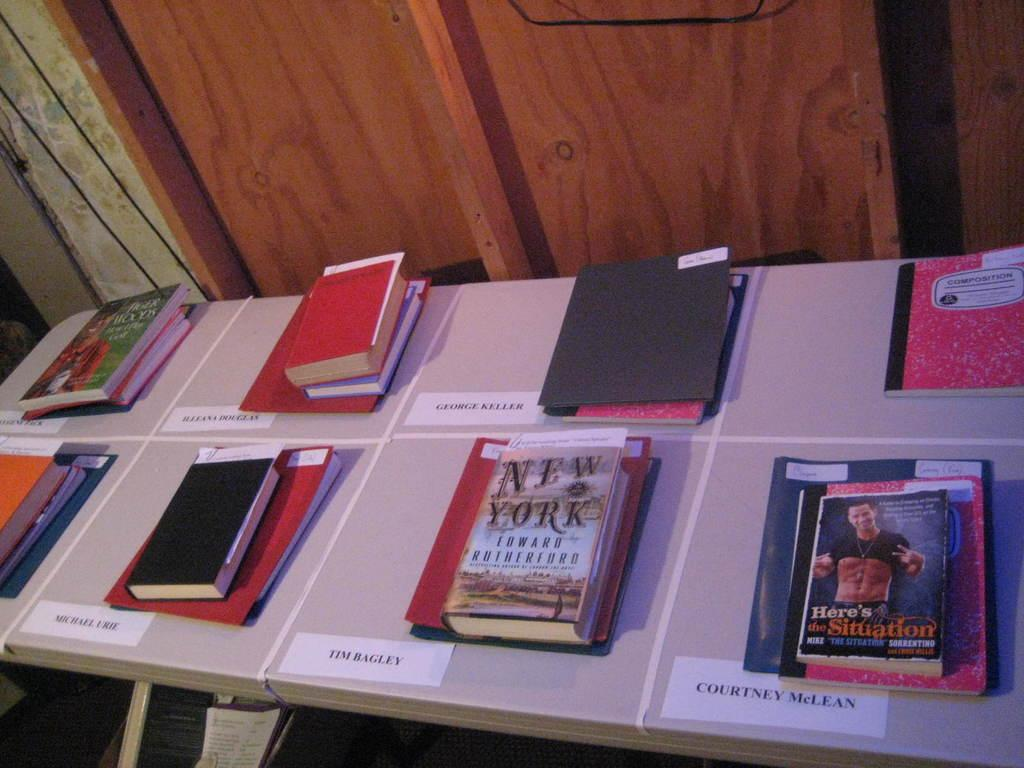<image>
Relay a brief, clear account of the picture shown. Books are on a white table with name tags such as one that is for Tim Bagley. 